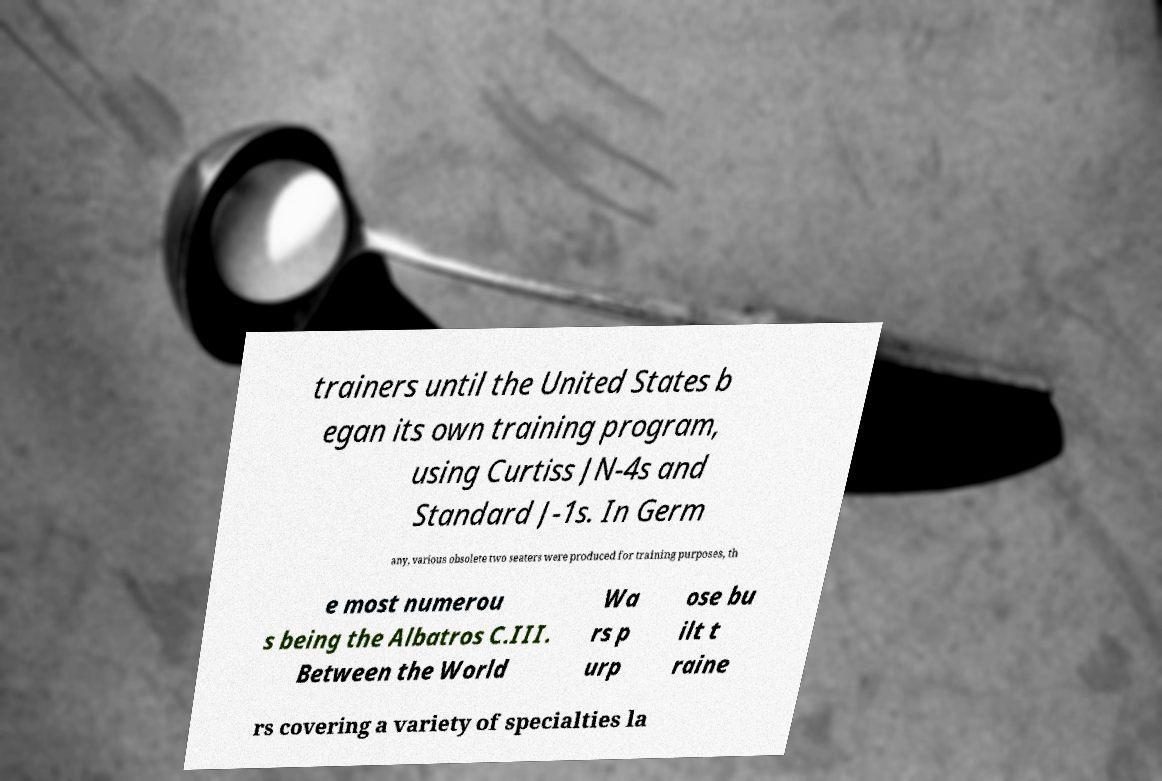Please read and relay the text visible in this image. What does it say? trainers until the United States b egan its own training program, using Curtiss JN-4s and Standard J-1s. In Germ any, various obsolete two seaters were produced for training purposes, th e most numerou s being the Albatros C.III. Between the World Wa rs p urp ose bu ilt t raine rs covering a variety of specialties la 